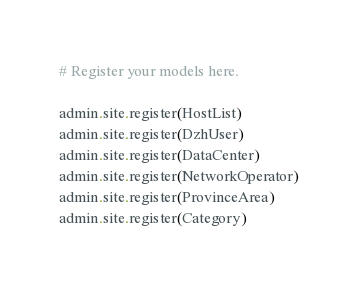Convert code to text. <code><loc_0><loc_0><loc_500><loc_500><_Python_># Register your models here.

admin.site.register(HostList)
admin.site.register(DzhUser)
admin.site.register(DataCenter)
admin.site.register(NetworkOperator)
admin.site.register(ProvinceArea)
admin.site.register(Category)</code> 